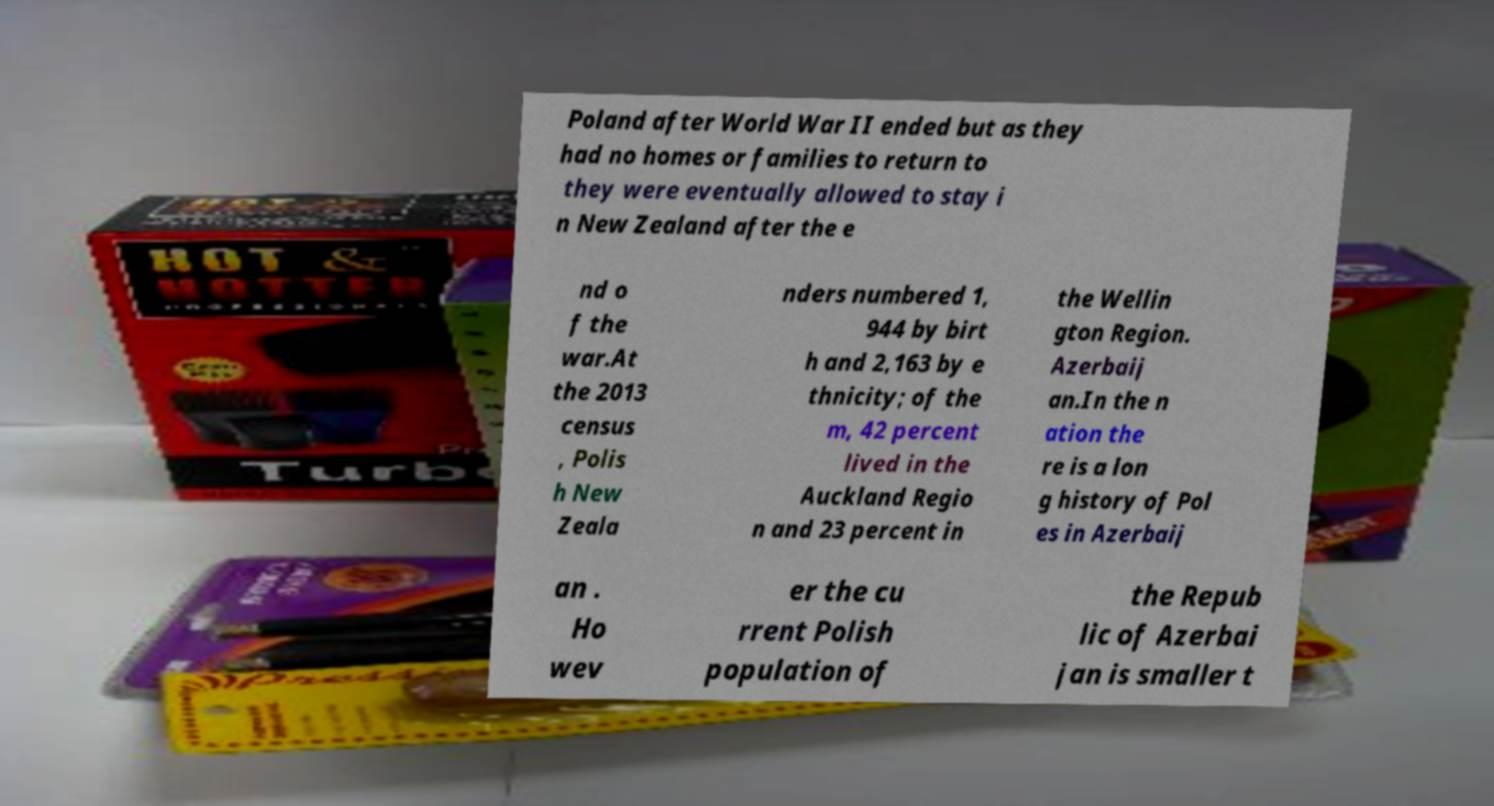Can you read and provide the text displayed in the image?This photo seems to have some interesting text. Can you extract and type it out for me? Poland after World War II ended but as they had no homes or families to return to they were eventually allowed to stay i n New Zealand after the e nd o f the war.At the 2013 census , Polis h New Zeala nders numbered 1, 944 by birt h and 2,163 by e thnicity; of the m, 42 percent lived in the Auckland Regio n and 23 percent in the Wellin gton Region. Azerbaij an.In the n ation the re is a lon g history of Pol es in Azerbaij an . Ho wev er the cu rrent Polish population of the Repub lic of Azerbai jan is smaller t 